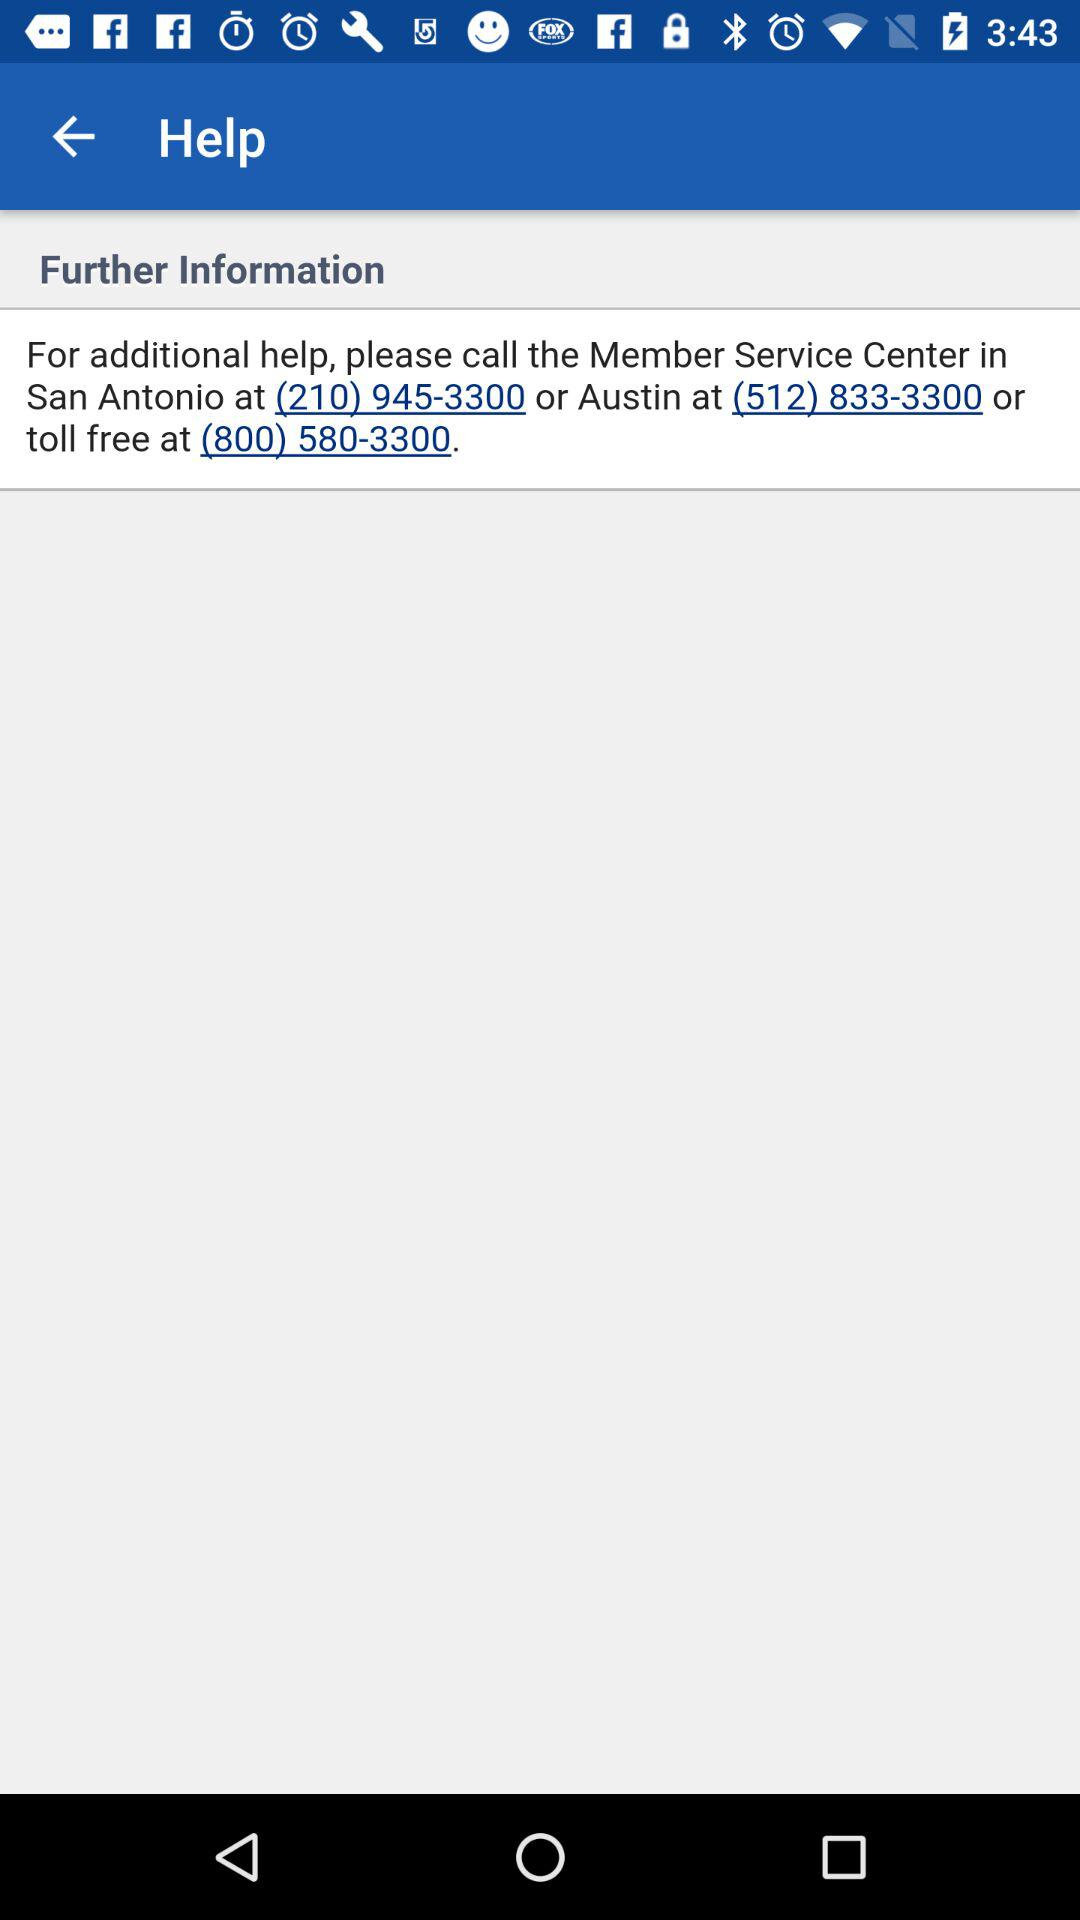What is the helpline number for San Antonio? The helpline number is (210) 945-3300. 